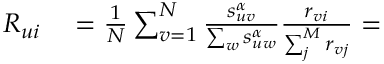Convert formula to latex. <formula><loc_0><loc_0><loc_500><loc_500>\begin{array} { r l } { R _ { u i } } & = \frac { 1 } { N } \sum _ { v = 1 } ^ { N } \frac { s _ { u v } ^ { \alpha } } { \sum _ { w } s _ { u w } ^ { \alpha } } \frac { r _ { v i } } { \sum _ { j } ^ { M } r _ { v j } } = } \end{array}</formula> 